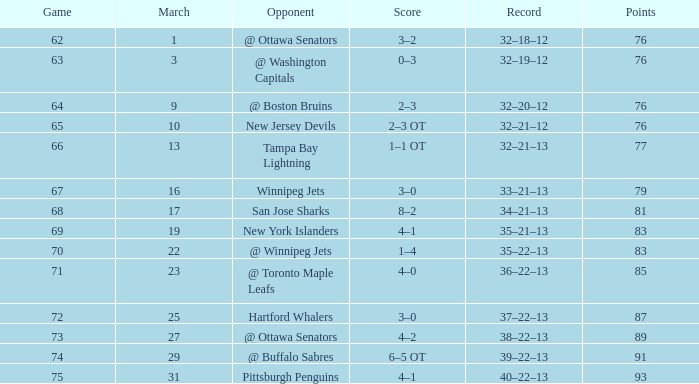Which Game is the lowest one that has a Score of 2–3 ot, and Points larger than 76? None. 